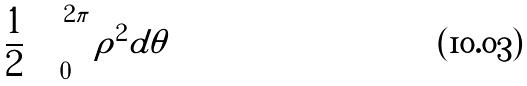Convert formula to latex. <formula><loc_0><loc_0><loc_500><loc_500>\frac { 1 } { 2 } \int _ { 0 } ^ { 2 \pi } \rho ^ { 2 } d \theta</formula> 